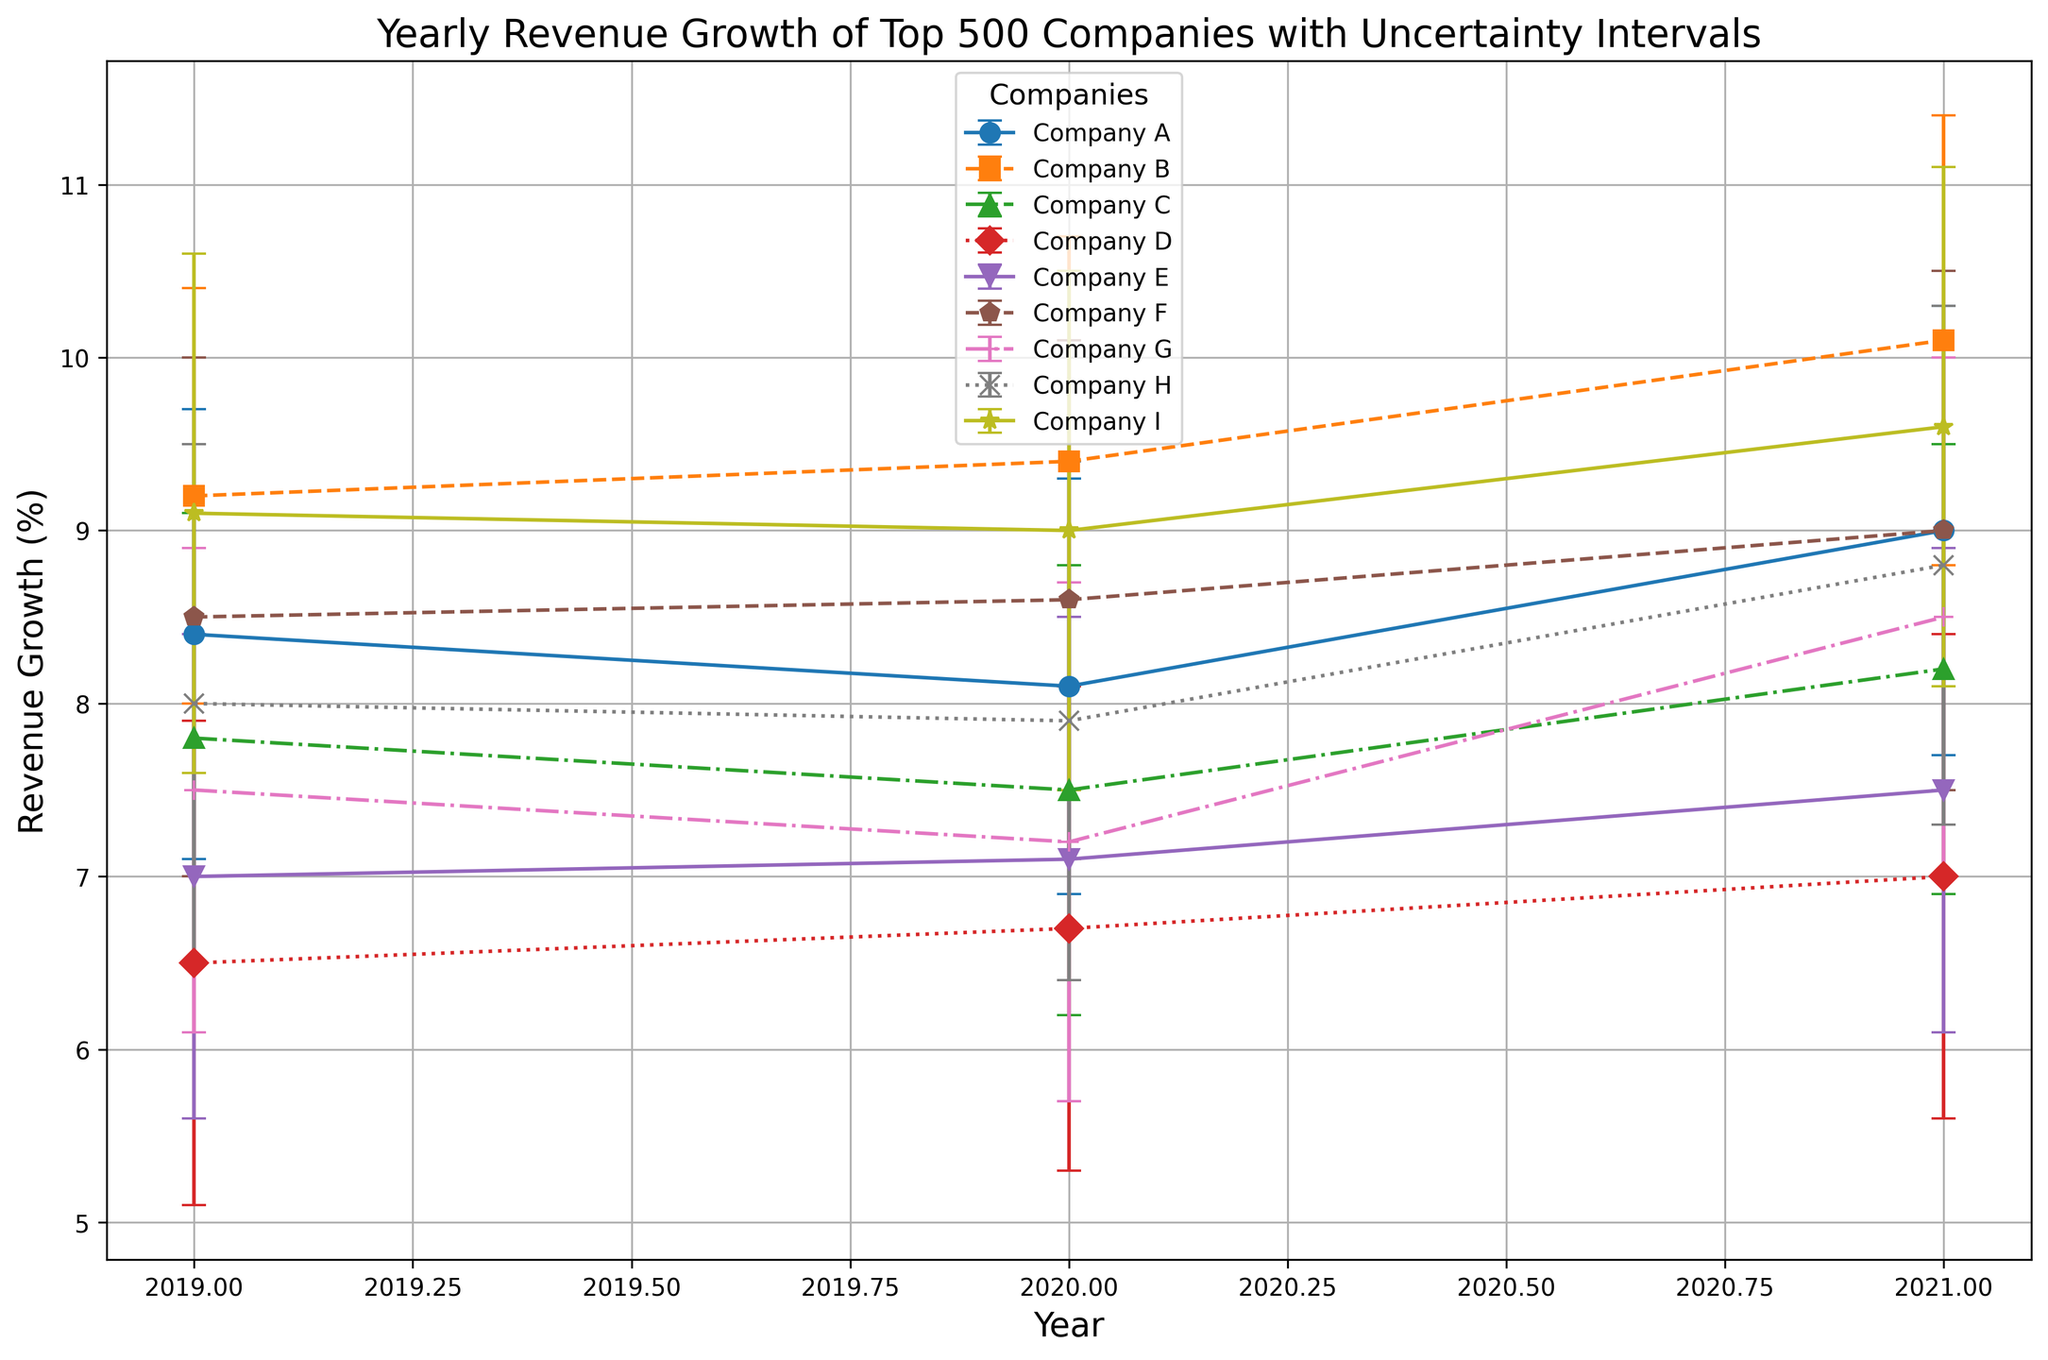What is the overall trend in the revenue growth of Company A from 2019 to 2021? First, identify Company A's revenue growth values from the chart for each year: 8.4% (2019), 8.1% (2020), and 9.0% (2021). Notice the growth decreases slightly from 2019 to 2020, then increases from 2020 to 2021. Overall, there is a slight upward trend.
Answer: Slight upward trend In which year did Company F experience the highest revenue growth, and what was the value? Locate the revenue growth points for Company F in each year: 8.5% (2019), 8.6% (2020), and 9.0% (2021). The highest value is in 2021.
Answer: 2021, 9.0% How does the revenue growth uncertainty of Company D compare between 2019 and 2021? Check the error bars for Company D in 2019 and 2021. In 2019, the lower bound is 6.5% - 5.1% = 1.4% and the upper bound is 7.9% - 6.5% = 1.4%. In 2021, the bounds are similar: 7.0% - 5.6% = 1.4% and 8.4% - 7.0% = 1.4%. The uncertainty remains the same between the two years.
Answer: Remains the same Which company had the most consistent revenue growth (least variation in growth) over the years 2019-2021? Analyze the revenue growth and uncertainty intervals for each company. Calculate the range (upper bound - lower bound) for each year and compare them. Company E has the smallest and almost constant intervals (e.g., 7.0%, 7.1%, 7.5% with very close bounds).
Answer: Company E Which company's revenue growth increased every year from 2019 to 2021? Track the revenue growth values for each company over the three years. Company I has values 9.1% (2019), 9.0% (2020), 9.6% (2021). This company's values show an increase from 2020 to 2021. However, since the values must increase each year without decline, none of the companies meet this specific criterion perfectly.
Answer: None Considering error bars, which companies had overlapping revenue growth intervals in 2021? Examine the error bars for 2021. If error bars intersect, it indicates overlapping intervals. Companies with overlapping intervals include many, such as Company A (8.0% - 10.3%) overlapping with Company H (7.3% - 10.3%).
Answer: Multiple companies What is the average revenue growth of Company B over the years 2019 to 2021? Calculate the average of Company B's revenue growth values: (9.2% + 9.4% + 10.1%) / 3. This results in (28.7%) / 3 = 9.5666%. Therefore, the average is approximately 9.57%.
Answer: 9.57% In 2021, which company had the smallest uncertainty in its revenue growth, and what was the value? Identify the length of the error bars in 2021 for each company. Company D in 2021 has growth bounds 7.0% with [5.6%, 8.4%]; thus, the uncertainty interval length is 1.4%. Next, review other companies: Company A has [7.7%, 10.3%] (2.6% interval), etc.
Answer: Company D, 1.4% 